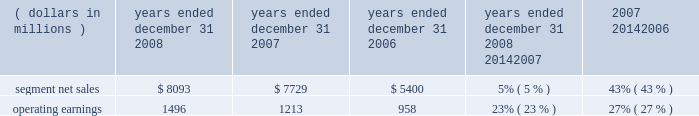The segment had operating earnings of $ 709 million in 2007 , compared to operating earnings of $ 787 million in 2006 .
The decrease in operating earnings was primarily due to a decrease in gross margin , driven by : ( i ) lower net sales of iden infrastructure equipment , and ( ii ) continued competitive pricing pressure in the market for gsm infrastructure equipment , partially offset by : ( i ) increased net sales of digital entertainment devices , and ( ii ) the reversal of reorganization of business accruals recorded in 2006 relating to employee severance which were no longer needed .
Sg&a expenses increased primarily due to the expenses from recently acquired businesses , partially offset by savings from cost-reduction initiatives .
R&d expenditures decreased primarily due to savings from cost- reduction initiatives , partially offset by expenditures by recently acquired businesses and continued investment in digital entertainment devices and wimax .
As a percentage of net sales in 2007 as compared to 2006 , gross margin , sg&a expenses , r&d expenditures and operating margin all decreased .
In 2007 , sales to the segment 2019s top five customers represented approximately 43% ( 43 % ) of the segment 2019s net sales .
The segment 2019s backlog was $ 2.6 billion at december 31 , 2007 , compared to $ 3.2 billion at december 31 , 2006 .
In the home business , demand for the segment 2019s products depends primarily on the level of capital spending by broadband operators for constructing , rebuilding or upgrading their communications systems , and for offering advanced services .
During the second quarter of 2007 , the segment began shipping digital set-tops that support the federal communications commission ( 201cfcc 201d ) 2014 mandated separable security requirement .
Fcc regulations mandating the separation of security functionality from set-tops went into effect on july 1 , 2007 .
As a result of these regulations , many cable service providers accelerated their purchases of set-tops in the first half of 2007 .
Additionally , in 2007 , our digital video customers significantly increased their purchases of the segment 2019s products and services , primarily due to increased demand for digital entertainment devices , particularly hd/dvr devices .
During 2007 , the segment completed the acquisitions of : ( i ) netopia , inc. , a broadband equipment provider for dsl customers , which allows for phone , tv and fast internet connections , ( ii ) tut systems , inc. , a leading developer of edge routing and video encoders , ( iii ) modulus video , inc. , a provider of mpeg-4 advanced coding compression systems designed for delivery of high-value video content in ip set-top devices for the digital video , broadcast and satellite marketplaces , ( iv ) terayon communication systems , inc. , a provider of real-time digital video networking applications to cable , satellite and telecommunication service providers worldwide , and ( v ) leapstone systems , inc. , a provider of intelligent multimedia service delivery and content management applications to networks operators .
These acquisitions enhance our ability to provide complete end-to-end systems for the delivery of advanced video , voice and data services .
In december 2007 , motorola completed the sale of ecc to emerson for $ 346 million in cash .
Enterprise mobility solutions segment the enterprise mobility solutions segment designs , manufactures , sells , installs and services analog and digital two-way radio , voice and data communications products and systems for private networks , wireless broadband systems and end-to-end enterprise mobility solutions to a wide range of enterprise markets , including government and public safety agencies ( which , together with all sales to distributors of two-way communication products , are referred to as the 201cgovernment and public safety market 201d ) , as well as retail , energy and utilities , transportation , manufacturing , healthcare and other commercial customers ( which , collectively , are referred to as the 201ccommercial enterprise market 201d ) .
In 2008 , the segment 2019s net sales represented 27% ( 27 % ) of the company 2019s consolidated net sales , compared to 21% ( 21 % ) in 2007 and 13% ( 13 % ) in 2006 .
( dollars in millions ) 2008 2007 2006 2008 20142007 2007 20142006 years ended december 31 percent change .
Segment results 20142008 compared to 2007 in 2008 , the segment 2019s net sales increased 5% ( 5 % ) to $ 8.1 billion , compared to $ 7.7 billion in 2007 .
The 5% ( 5 % ) increase in net sales reflects an 8% ( 8 % ) increase in net sales to the government and public safety market , partially offset by a 2% ( 2 % ) decrease in net sales to the commercial enterprise market .
The increase in net sales to the government and public safety market was primarily driven by : ( i ) increased net sales outside of north america , and ( ii ) the net sales generated by vertex standard co. , ltd. , a business the company acquired a controlling interest of in january 2008 , partially offset by lower net sales in north america .
On a geographic basis , the segment 2019s net sales were higher in emea , asia and latin america and lower in north america .
65management 2019s discussion and analysis of financial condition and results of operations %%transmsg*** transmitting job : c49054 pcn : 068000000 ***%%pcmsg|65 |00024|yes|no|02/24/2009 12:31|0|0|page is valid , no graphics -- color : n| .
What was the percentage of consolidated net sales from 2006 to 2008? 
Rationale: to find the consolidated net sales one must take the percentages given in line 17 and multiple it by the segmented net sales given in the table . the two products are then subtracted from each other . the answer is then divided by the consolidated net sales for 2006 .
Computations: (((8093 * 27%) - (5400 * 13%)) / (5400 * 13%))
Answer: 2.11269. 